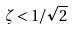<formula> <loc_0><loc_0><loc_500><loc_500>\zeta < 1 / \sqrt { 2 }</formula> 